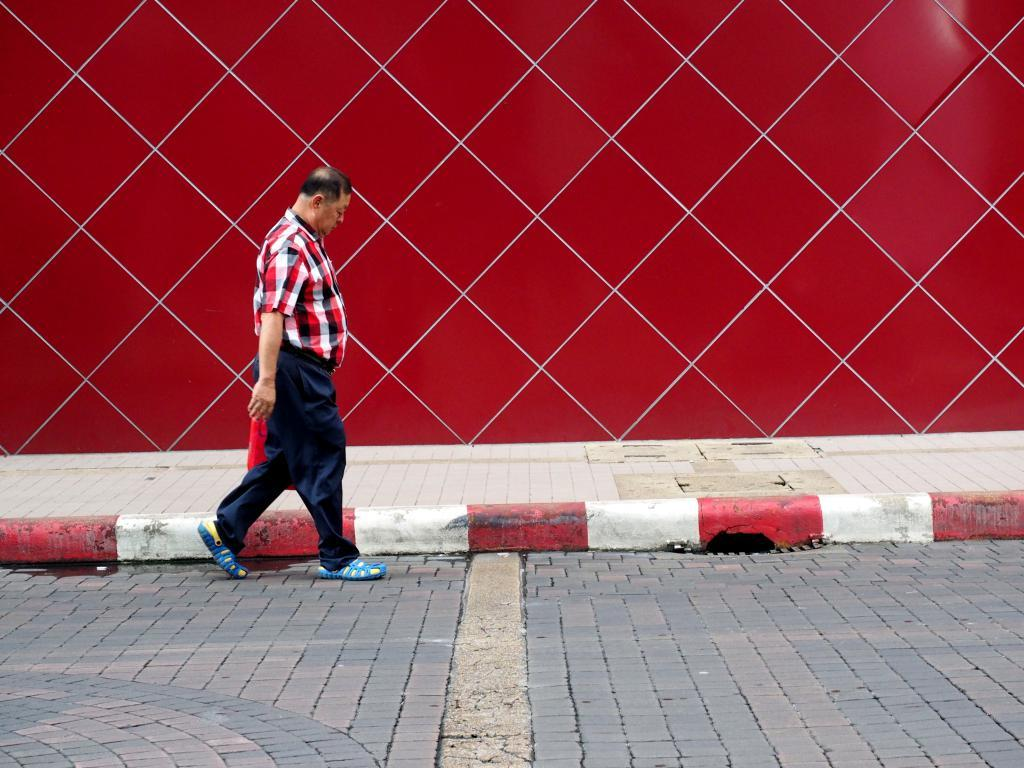What is the main subject of the image? There is a person walking in the image. What is the person walking on? The person is walking on the ground. What color can be seen in the background of the image? There is a red color visible in the background of the image. What type of cake is the person's daughter holding in the image? There is no cake or daughter present in the image; it only features a person walking on the ground. 